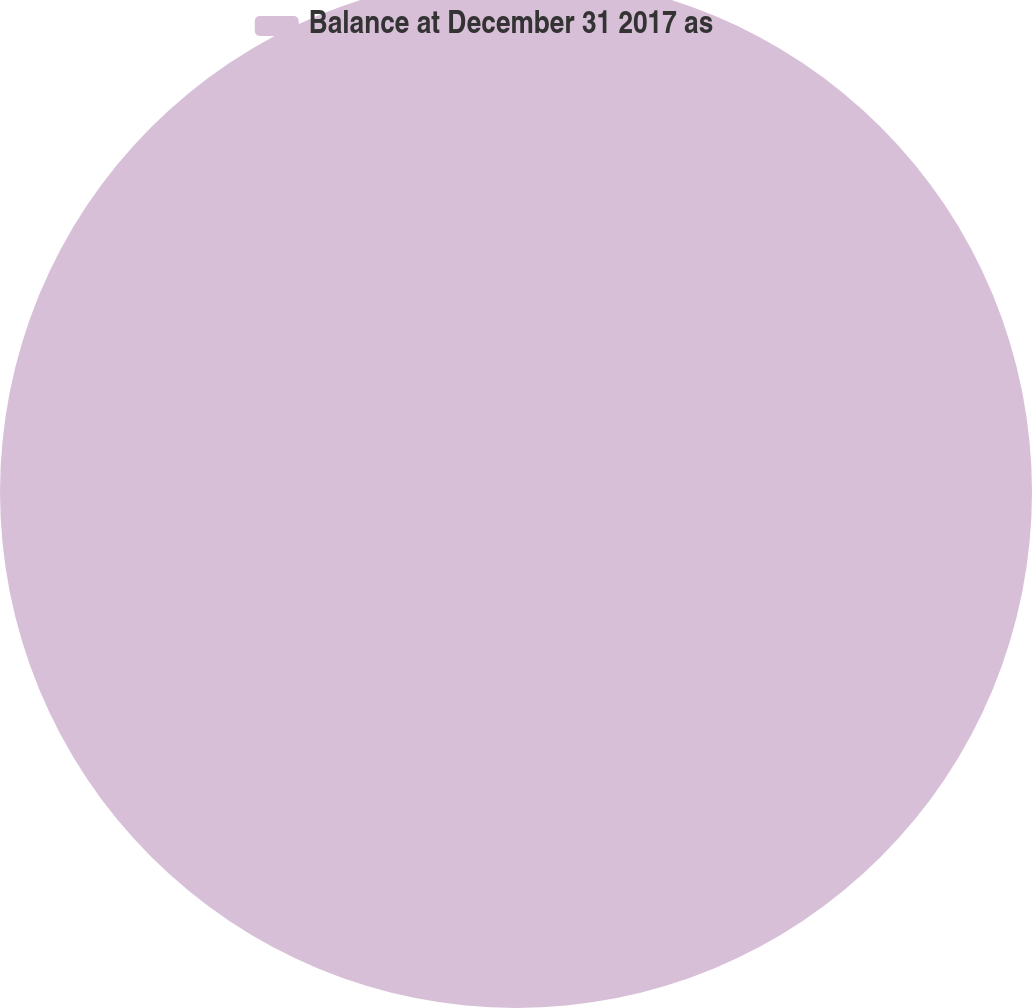<chart> <loc_0><loc_0><loc_500><loc_500><pie_chart><fcel>Balance at December 31 2017 as<nl><fcel>100.0%<nl></chart> 